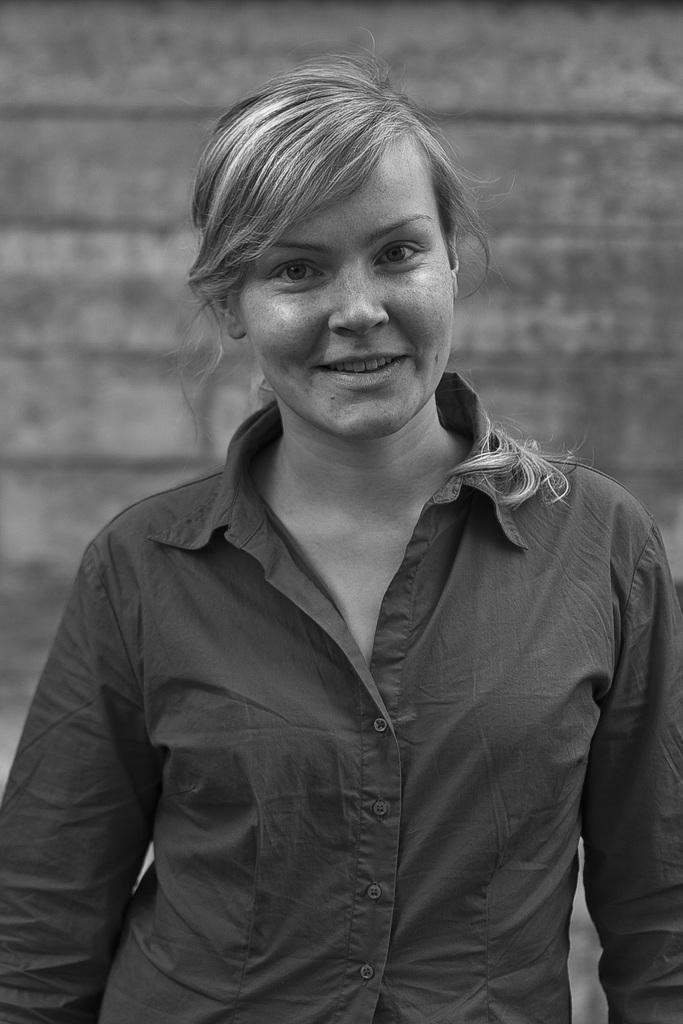Who is present in the image? There is a woman in the image. What is the woman wearing? The woman is wearing a shirt. What is the woman's facial expression? The woman is smiling. What is the woman's posture in the image? The woman is standing. How would you describe the background of the image? The background of the image is blurred. Is the woman sleeping in the image? No, the woman is not sleeping in the image; she is standing and smiling. Can you see a bear in the image? No, there is no bear present in the image. 